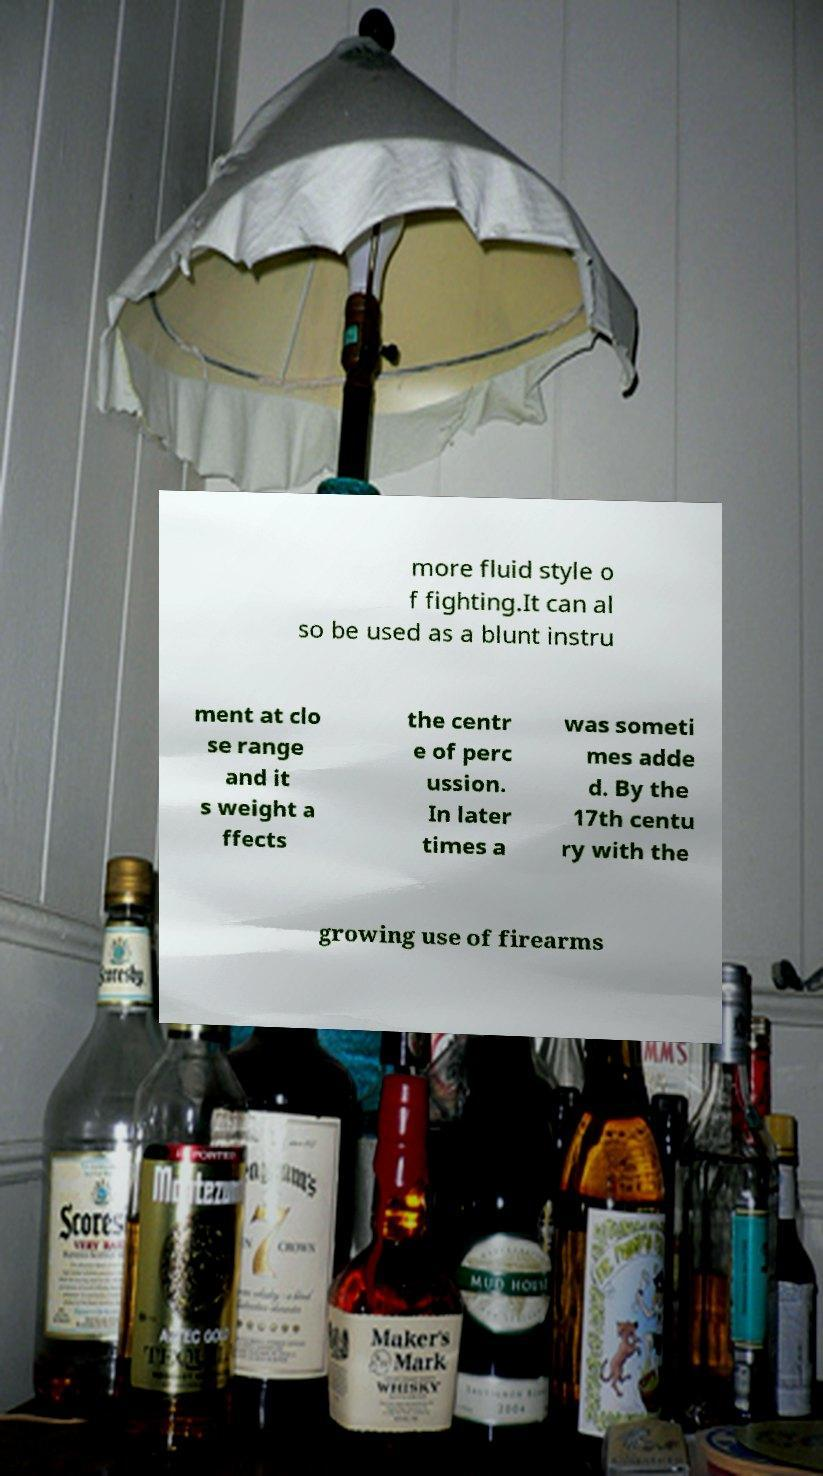There's text embedded in this image that I need extracted. Can you transcribe it verbatim? more fluid style o f fighting.It can al so be used as a blunt instru ment at clo se range and it s weight a ffects the centr e of perc ussion. In later times a was someti mes adde d. By the 17th centu ry with the growing use of firearms 